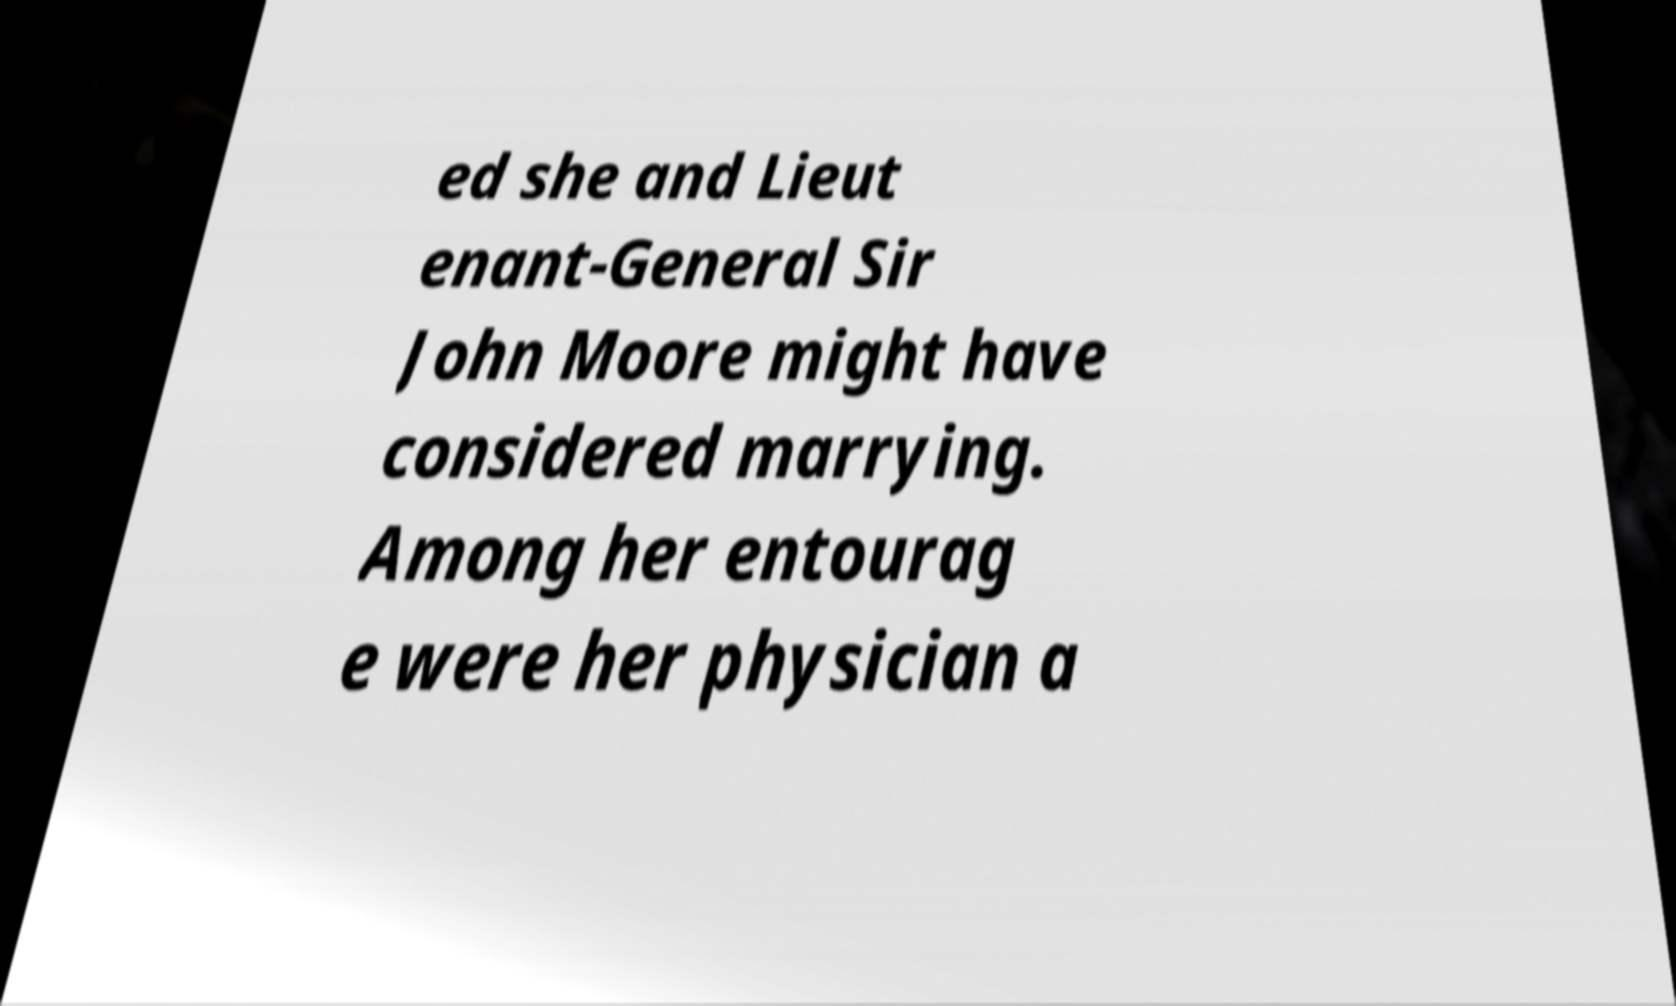Please identify and transcribe the text found in this image. ed she and Lieut enant-General Sir John Moore might have considered marrying. Among her entourag e were her physician a 